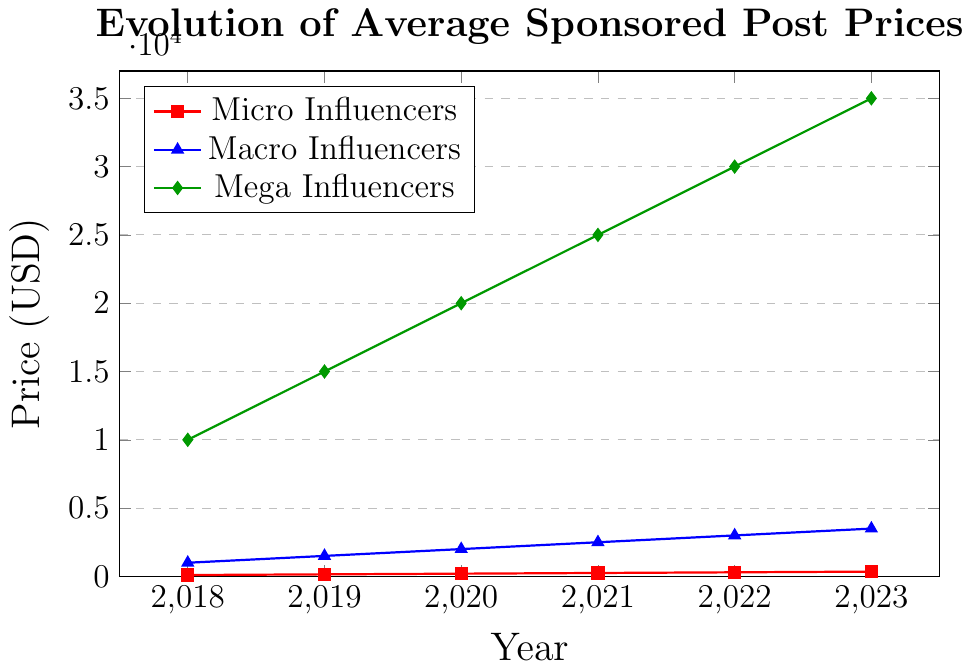What was the average price for sponsored posts by Micro Influencers over the years? Sum the prices of Micro Influencers from 2018 to 2023: 100 + 150 + 200 + 250 + 300 + 350 = 1350. The average price is 1350 divided by 6 years.
Answer: 225 How much more did Mega Influencers charge compared to Macro Influencers in 2020? For 2020, subtract the price of Macro Influencers from that of Mega Influencers: 20000 - 2000 = 18000.
Answer: 18000 In which year did Macro Influencers prices reach half the price of Mega Influencers? Check each year: in 2021, Macro Influencers charged 2500, which is exactly half of Mega Influencers' 25000.
Answer: 2021 Which influencer group saw the largest absolute increase in sponsored post price from 2018 to 2023? Calculate the increase for each group: Micro Influencers increased by 350 - 100 = 250, Macro Influencers by 3500 - 1000 = 2500, and Mega Influencers by 35000 - 10000 = 25000. The largest increase is for Mega Influencers.
Answer: Mega Influencers What is the total combined price for all three influencer groups in 2022? Add the prices for all influencer groups in 2022: 300 (Micro) + 3000 (Macro) + 30000 (Mega) = 33300.
Answer: 33300 By what percentage did the price for Macro Influencers rise from 2018 to 2023? Calculate the increase: 3500 - 1000 = 2500. Then compute the percentage increase based on the initial price: (2500 / 1000) * 100 = 250%.
Answer: 250% Did any influencer group see a doubling in their sponsored post prices between any two consecutive years? Compare each year pair for each group: Micro Influencers from 2018 to 2019 rose from 100 to 150, not doubled. Macro Influencers from 2018 to 2019 rose from 1000 to 1500, not doubled. Mega Influencers from 2018 to 2019 rose from 10000 to 15000, not doubled. Hence, no group saw a doubling in their prices in any two consecutive years.
Answer: No Which influencer group had the steepest price curve based on visual inspection? By visually comparing the steepness of the lines, Mega Influencers have the steepest upward curve.
Answer: Mega Influencers Between 2019 and 2021, which influencer group had the smallest increase in price? Determine the price increase for each group: Micro Influencers went from 150 to 250, so an increase of 100. Macro Influencers went from 1500 to 2500, so an increase of 1000. Mega Influencers went from 15000 to 25000, so an increase of 10000. The smallest increase is for Micro Influencers.
Answer: Micro Influencers 